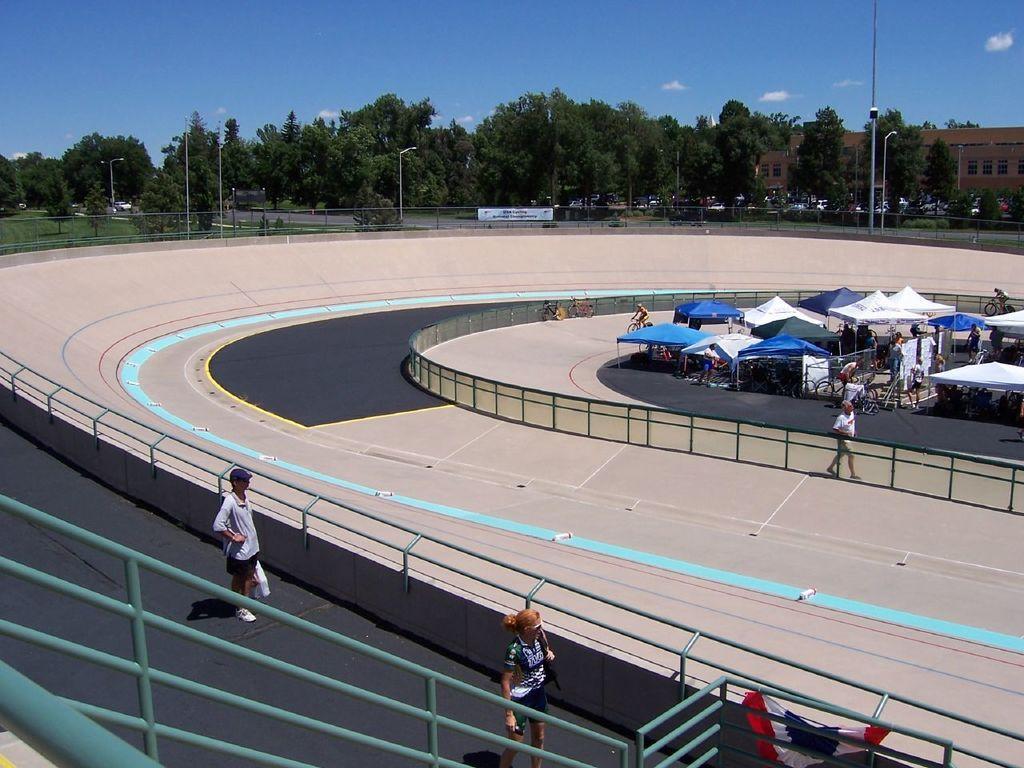In one or two sentences, can you explain what this image depicts? In this image there is the sky, there are clouds in the sky, there are trees, there is a building truncated towards the right of the image, there is a tree truncated towards the left of the image, there is the grass, there are poles, there are street lights, there is board, there is text on the boards, there are tents, there are tents truncated towards the right of the image, there are bicycles, there are persons, there is a flag, there is a racing track, there are metal rods truncated towards the bottom of the image. 